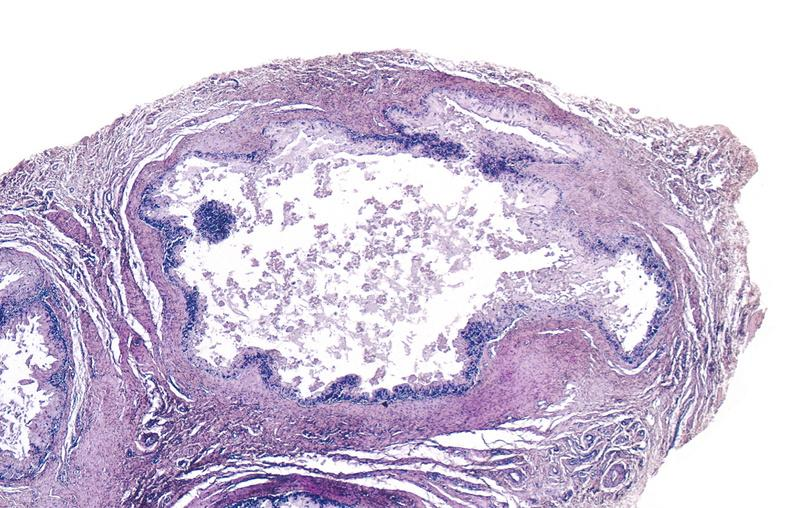does hyperplasia median bar show gout?
Answer the question using a single word or phrase. No 